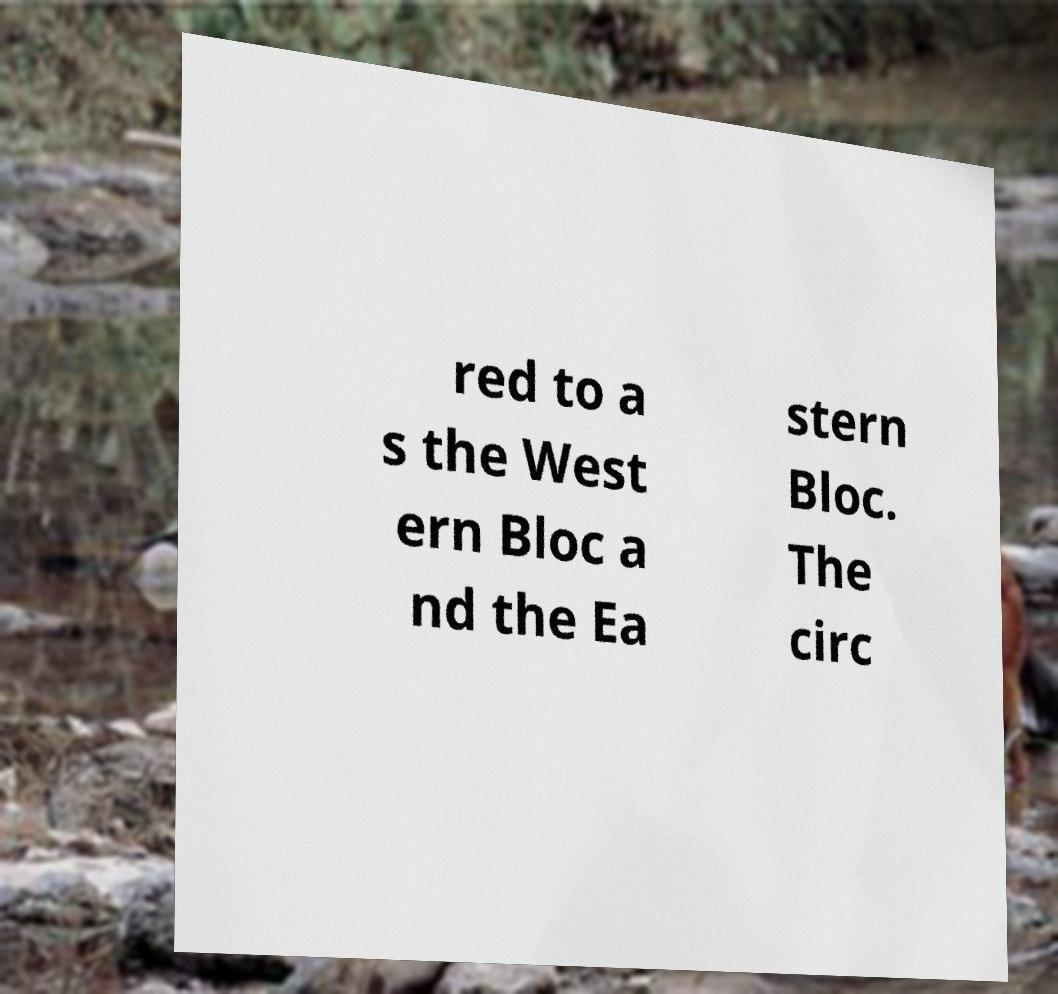I need the written content from this picture converted into text. Can you do that? red to a s the West ern Bloc a nd the Ea stern Bloc. The circ 